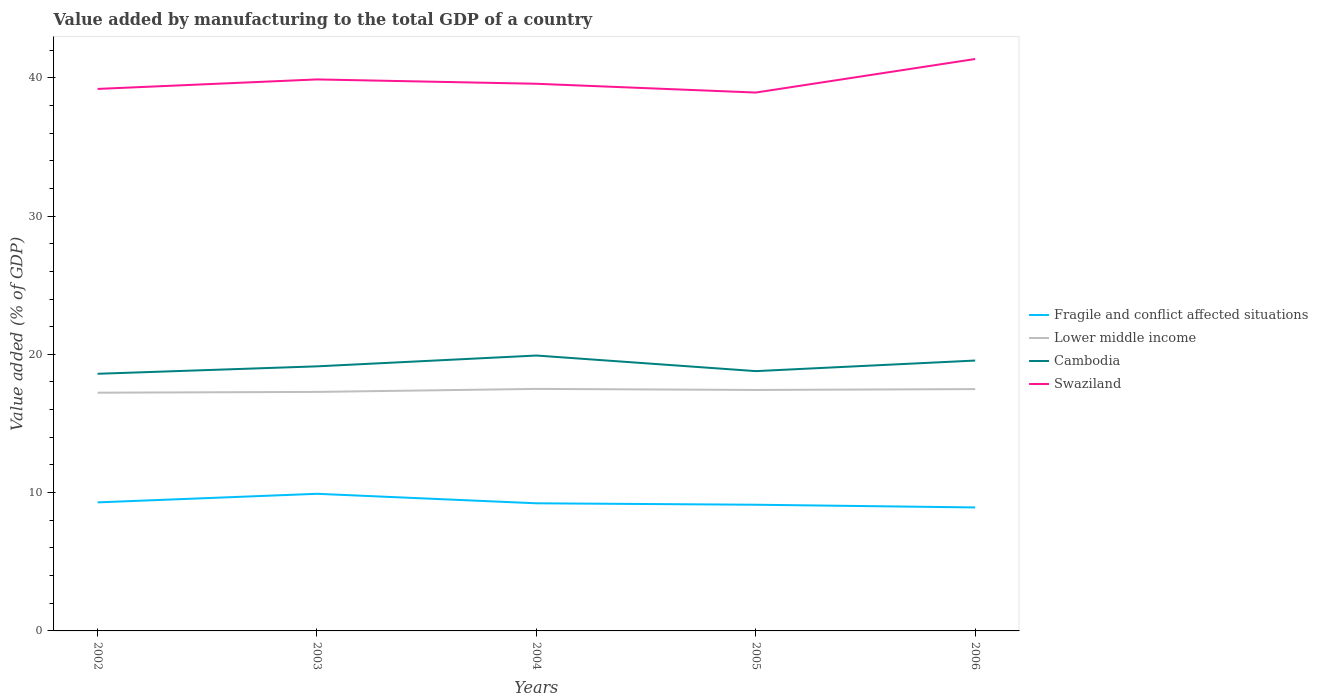Is the number of lines equal to the number of legend labels?
Your answer should be very brief. Yes. Across all years, what is the maximum value added by manufacturing to the total GDP in Cambodia?
Provide a short and direct response. 18.59. In which year was the value added by manufacturing to the total GDP in Fragile and conflict affected situations maximum?
Make the answer very short. 2006. What is the total value added by manufacturing to the total GDP in Cambodia in the graph?
Your response must be concise. -0.77. What is the difference between the highest and the second highest value added by manufacturing to the total GDP in Swaziland?
Your answer should be compact. 2.43. Is the value added by manufacturing to the total GDP in Cambodia strictly greater than the value added by manufacturing to the total GDP in Swaziland over the years?
Offer a very short reply. Yes. How many lines are there?
Provide a succinct answer. 4. How many years are there in the graph?
Your answer should be compact. 5. What is the difference between two consecutive major ticks on the Y-axis?
Provide a succinct answer. 10. Does the graph contain grids?
Ensure brevity in your answer.  No. How are the legend labels stacked?
Keep it short and to the point. Vertical. What is the title of the graph?
Give a very brief answer. Value added by manufacturing to the total GDP of a country. What is the label or title of the X-axis?
Provide a short and direct response. Years. What is the label or title of the Y-axis?
Ensure brevity in your answer.  Value added (% of GDP). What is the Value added (% of GDP) of Fragile and conflict affected situations in 2002?
Make the answer very short. 9.3. What is the Value added (% of GDP) in Lower middle income in 2002?
Offer a very short reply. 17.23. What is the Value added (% of GDP) in Cambodia in 2002?
Your response must be concise. 18.59. What is the Value added (% of GDP) in Swaziland in 2002?
Your answer should be very brief. 39.19. What is the Value added (% of GDP) in Fragile and conflict affected situations in 2003?
Give a very brief answer. 9.92. What is the Value added (% of GDP) of Lower middle income in 2003?
Offer a terse response. 17.28. What is the Value added (% of GDP) of Cambodia in 2003?
Provide a succinct answer. 19.13. What is the Value added (% of GDP) in Swaziland in 2003?
Provide a succinct answer. 39.88. What is the Value added (% of GDP) in Fragile and conflict affected situations in 2004?
Ensure brevity in your answer.  9.23. What is the Value added (% of GDP) of Lower middle income in 2004?
Provide a succinct answer. 17.5. What is the Value added (% of GDP) in Cambodia in 2004?
Your answer should be very brief. 19.91. What is the Value added (% of GDP) in Swaziland in 2004?
Offer a very short reply. 39.56. What is the Value added (% of GDP) in Fragile and conflict affected situations in 2005?
Your answer should be very brief. 9.12. What is the Value added (% of GDP) in Lower middle income in 2005?
Provide a succinct answer. 17.42. What is the Value added (% of GDP) in Cambodia in 2005?
Ensure brevity in your answer.  18.79. What is the Value added (% of GDP) in Swaziland in 2005?
Offer a terse response. 38.93. What is the Value added (% of GDP) in Fragile and conflict affected situations in 2006?
Provide a succinct answer. 8.93. What is the Value added (% of GDP) of Lower middle income in 2006?
Keep it short and to the point. 17.49. What is the Value added (% of GDP) of Cambodia in 2006?
Your answer should be compact. 19.55. What is the Value added (% of GDP) in Swaziland in 2006?
Your answer should be compact. 41.35. Across all years, what is the maximum Value added (% of GDP) in Fragile and conflict affected situations?
Ensure brevity in your answer.  9.92. Across all years, what is the maximum Value added (% of GDP) in Lower middle income?
Keep it short and to the point. 17.5. Across all years, what is the maximum Value added (% of GDP) in Cambodia?
Your answer should be very brief. 19.91. Across all years, what is the maximum Value added (% of GDP) of Swaziland?
Provide a succinct answer. 41.35. Across all years, what is the minimum Value added (% of GDP) of Fragile and conflict affected situations?
Offer a very short reply. 8.93. Across all years, what is the minimum Value added (% of GDP) of Lower middle income?
Offer a terse response. 17.23. Across all years, what is the minimum Value added (% of GDP) in Cambodia?
Your response must be concise. 18.59. Across all years, what is the minimum Value added (% of GDP) in Swaziland?
Make the answer very short. 38.93. What is the total Value added (% of GDP) of Fragile and conflict affected situations in the graph?
Keep it short and to the point. 46.49. What is the total Value added (% of GDP) in Lower middle income in the graph?
Your answer should be very brief. 86.92. What is the total Value added (% of GDP) in Cambodia in the graph?
Your answer should be compact. 95.97. What is the total Value added (% of GDP) in Swaziland in the graph?
Ensure brevity in your answer.  198.91. What is the difference between the Value added (% of GDP) in Fragile and conflict affected situations in 2002 and that in 2003?
Your answer should be compact. -0.62. What is the difference between the Value added (% of GDP) of Lower middle income in 2002 and that in 2003?
Give a very brief answer. -0.06. What is the difference between the Value added (% of GDP) in Cambodia in 2002 and that in 2003?
Ensure brevity in your answer.  -0.54. What is the difference between the Value added (% of GDP) in Swaziland in 2002 and that in 2003?
Offer a very short reply. -0.69. What is the difference between the Value added (% of GDP) of Fragile and conflict affected situations in 2002 and that in 2004?
Your response must be concise. 0.07. What is the difference between the Value added (% of GDP) in Lower middle income in 2002 and that in 2004?
Keep it short and to the point. -0.27. What is the difference between the Value added (% of GDP) in Cambodia in 2002 and that in 2004?
Ensure brevity in your answer.  -1.32. What is the difference between the Value added (% of GDP) of Swaziland in 2002 and that in 2004?
Your answer should be compact. -0.37. What is the difference between the Value added (% of GDP) of Fragile and conflict affected situations in 2002 and that in 2005?
Make the answer very short. 0.17. What is the difference between the Value added (% of GDP) in Lower middle income in 2002 and that in 2005?
Give a very brief answer. -0.2. What is the difference between the Value added (% of GDP) of Cambodia in 2002 and that in 2005?
Offer a terse response. -0.19. What is the difference between the Value added (% of GDP) in Swaziland in 2002 and that in 2005?
Your answer should be very brief. 0.26. What is the difference between the Value added (% of GDP) of Fragile and conflict affected situations in 2002 and that in 2006?
Keep it short and to the point. 0.37. What is the difference between the Value added (% of GDP) of Lower middle income in 2002 and that in 2006?
Make the answer very short. -0.26. What is the difference between the Value added (% of GDP) of Cambodia in 2002 and that in 2006?
Provide a succinct answer. -0.96. What is the difference between the Value added (% of GDP) in Swaziland in 2002 and that in 2006?
Provide a short and direct response. -2.16. What is the difference between the Value added (% of GDP) of Fragile and conflict affected situations in 2003 and that in 2004?
Your answer should be very brief. 0.69. What is the difference between the Value added (% of GDP) in Lower middle income in 2003 and that in 2004?
Offer a very short reply. -0.22. What is the difference between the Value added (% of GDP) of Cambodia in 2003 and that in 2004?
Offer a terse response. -0.78. What is the difference between the Value added (% of GDP) of Swaziland in 2003 and that in 2004?
Your answer should be very brief. 0.31. What is the difference between the Value added (% of GDP) in Fragile and conflict affected situations in 2003 and that in 2005?
Your answer should be compact. 0.79. What is the difference between the Value added (% of GDP) of Lower middle income in 2003 and that in 2005?
Your answer should be compact. -0.14. What is the difference between the Value added (% of GDP) in Cambodia in 2003 and that in 2005?
Offer a very short reply. 0.35. What is the difference between the Value added (% of GDP) in Swaziland in 2003 and that in 2005?
Give a very brief answer. 0.95. What is the difference between the Value added (% of GDP) in Fragile and conflict affected situations in 2003 and that in 2006?
Ensure brevity in your answer.  0.99. What is the difference between the Value added (% of GDP) in Lower middle income in 2003 and that in 2006?
Provide a short and direct response. -0.2. What is the difference between the Value added (% of GDP) of Cambodia in 2003 and that in 2006?
Offer a terse response. -0.42. What is the difference between the Value added (% of GDP) in Swaziland in 2003 and that in 2006?
Keep it short and to the point. -1.48. What is the difference between the Value added (% of GDP) in Fragile and conflict affected situations in 2004 and that in 2005?
Your answer should be very brief. 0.1. What is the difference between the Value added (% of GDP) in Lower middle income in 2004 and that in 2005?
Offer a terse response. 0.08. What is the difference between the Value added (% of GDP) of Cambodia in 2004 and that in 2005?
Your answer should be compact. 1.13. What is the difference between the Value added (% of GDP) of Swaziland in 2004 and that in 2005?
Offer a terse response. 0.64. What is the difference between the Value added (% of GDP) of Fragile and conflict affected situations in 2004 and that in 2006?
Keep it short and to the point. 0.3. What is the difference between the Value added (% of GDP) of Lower middle income in 2004 and that in 2006?
Provide a short and direct response. 0.01. What is the difference between the Value added (% of GDP) in Cambodia in 2004 and that in 2006?
Make the answer very short. 0.36. What is the difference between the Value added (% of GDP) of Swaziland in 2004 and that in 2006?
Ensure brevity in your answer.  -1.79. What is the difference between the Value added (% of GDP) of Fragile and conflict affected situations in 2005 and that in 2006?
Make the answer very short. 0.2. What is the difference between the Value added (% of GDP) in Lower middle income in 2005 and that in 2006?
Make the answer very short. -0.06. What is the difference between the Value added (% of GDP) in Cambodia in 2005 and that in 2006?
Provide a succinct answer. -0.77. What is the difference between the Value added (% of GDP) of Swaziland in 2005 and that in 2006?
Ensure brevity in your answer.  -2.43. What is the difference between the Value added (% of GDP) in Fragile and conflict affected situations in 2002 and the Value added (% of GDP) in Lower middle income in 2003?
Your answer should be very brief. -7.99. What is the difference between the Value added (% of GDP) in Fragile and conflict affected situations in 2002 and the Value added (% of GDP) in Cambodia in 2003?
Offer a terse response. -9.84. What is the difference between the Value added (% of GDP) of Fragile and conflict affected situations in 2002 and the Value added (% of GDP) of Swaziland in 2003?
Your answer should be compact. -30.58. What is the difference between the Value added (% of GDP) in Lower middle income in 2002 and the Value added (% of GDP) in Cambodia in 2003?
Keep it short and to the point. -1.9. What is the difference between the Value added (% of GDP) of Lower middle income in 2002 and the Value added (% of GDP) of Swaziland in 2003?
Offer a very short reply. -22.65. What is the difference between the Value added (% of GDP) in Cambodia in 2002 and the Value added (% of GDP) in Swaziland in 2003?
Provide a short and direct response. -21.28. What is the difference between the Value added (% of GDP) of Fragile and conflict affected situations in 2002 and the Value added (% of GDP) of Lower middle income in 2004?
Your answer should be very brief. -8.2. What is the difference between the Value added (% of GDP) of Fragile and conflict affected situations in 2002 and the Value added (% of GDP) of Cambodia in 2004?
Make the answer very short. -10.62. What is the difference between the Value added (% of GDP) in Fragile and conflict affected situations in 2002 and the Value added (% of GDP) in Swaziland in 2004?
Your response must be concise. -30.27. What is the difference between the Value added (% of GDP) of Lower middle income in 2002 and the Value added (% of GDP) of Cambodia in 2004?
Your answer should be compact. -2.69. What is the difference between the Value added (% of GDP) of Lower middle income in 2002 and the Value added (% of GDP) of Swaziland in 2004?
Make the answer very short. -22.34. What is the difference between the Value added (% of GDP) of Cambodia in 2002 and the Value added (% of GDP) of Swaziland in 2004?
Offer a very short reply. -20.97. What is the difference between the Value added (% of GDP) in Fragile and conflict affected situations in 2002 and the Value added (% of GDP) in Lower middle income in 2005?
Ensure brevity in your answer.  -8.13. What is the difference between the Value added (% of GDP) in Fragile and conflict affected situations in 2002 and the Value added (% of GDP) in Cambodia in 2005?
Offer a very short reply. -9.49. What is the difference between the Value added (% of GDP) of Fragile and conflict affected situations in 2002 and the Value added (% of GDP) of Swaziland in 2005?
Your answer should be very brief. -29.63. What is the difference between the Value added (% of GDP) in Lower middle income in 2002 and the Value added (% of GDP) in Cambodia in 2005?
Give a very brief answer. -1.56. What is the difference between the Value added (% of GDP) of Lower middle income in 2002 and the Value added (% of GDP) of Swaziland in 2005?
Give a very brief answer. -21.7. What is the difference between the Value added (% of GDP) of Cambodia in 2002 and the Value added (% of GDP) of Swaziland in 2005?
Make the answer very short. -20.33. What is the difference between the Value added (% of GDP) of Fragile and conflict affected situations in 2002 and the Value added (% of GDP) of Lower middle income in 2006?
Offer a very short reply. -8.19. What is the difference between the Value added (% of GDP) in Fragile and conflict affected situations in 2002 and the Value added (% of GDP) in Cambodia in 2006?
Keep it short and to the point. -10.26. What is the difference between the Value added (% of GDP) of Fragile and conflict affected situations in 2002 and the Value added (% of GDP) of Swaziland in 2006?
Keep it short and to the point. -32.06. What is the difference between the Value added (% of GDP) of Lower middle income in 2002 and the Value added (% of GDP) of Cambodia in 2006?
Ensure brevity in your answer.  -2.32. What is the difference between the Value added (% of GDP) in Lower middle income in 2002 and the Value added (% of GDP) in Swaziland in 2006?
Keep it short and to the point. -24.13. What is the difference between the Value added (% of GDP) in Cambodia in 2002 and the Value added (% of GDP) in Swaziland in 2006?
Your response must be concise. -22.76. What is the difference between the Value added (% of GDP) in Fragile and conflict affected situations in 2003 and the Value added (% of GDP) in Lower middle income in 2004?
Keep it short and to the point. -7.58. What is the difference between the Value added (% of GDP) in Fragile and conflict affected situations in 2003 and the Value added (% of GDP) in Cambodia in 2004?
Ensure brevity in your answer.  -10. What is the difference between the Value added (% of GDP) of Fragile and conflict affected situations in 2003 and the Value added (% of GDP) of Swaziland in 2004?
Your response must be concise. -29.65. What is the difference between the Value added (% of GDP) of Lower middle income in 2003 and the Value added (% of GDP) of Cambodia in 2004?
Offer a very short reply. -2.63. What is the difference between the Value added (% of GDP) of Lower middle income in 2003 and the Value added (% of GDP) of Swaziland in 2004?
Give a very brief answer. -22.28. What is the difference between the Value added (% of GDP) of Cambodia in 2003 and the Value added (% of GDP) of Swaziland in 2004?
Provide a short and direct response. -20.43. What is the difference between the Value added (% of GDP) of Fragile and conflict affected situations in 2003 and the Value added (% of GDP) of Lower middle income in 2005?
Your response must be concise. -7.51. What is the difference between the Value added (% of GDP) in Fragile and conflict affected situations in 2003 and the Value added (% of GDP) in Cambodia in 2005?
Provide a succinct answer. -8.87. What is the difference between the Value added (% of GDP) in Fragile and conflict affected situations in 2003 and the Value added (% of GDP) in Swaziland in 2005?
Your answer should be very brief. -29.01. What is the difference between the Value added (% of GDP) of Lower middle income in 2003 and the Value added (% of GDP) of Cambodia in 2005?
Your response must be concise. -1.5. What is the difference between the Value added (% of GDP) in Lower middle income in 2003 and the Value added (% of GDP) in Swaziland in 2005?
Your answer should be compact. -21.65. What is the difference between the Value added (% of GDP) in Cambodia in 2003 and the Value added (% of GDP) in Swaziland in 2005?
Make the answer very short. -19.8. What is the difference between the Value added (% of GDP) in Fragile and conflict affected situations in 2003 and the Value added (% of GDP) in Lower middle income in 2006?
Give a very brief answer. -7.57. What is the difference between the Value added (% of GDP) in Fragile and conflict affected situations in 2003 and the Value added (% of GDP) in Cambodia in 2006?
Keep it short and to the point. -9.64. What is the difference between the Value added (% of GDP) in Fragile and conflict affected situations in 2003 and the Value added (% of GDP) in Swaziland in 2006?
Your answer should be compact. -31.44. What is the difference between the Value added (% of GDP) of Lower middle income in 2003 and the Value added (% of GDP) of Cambodia in 2006?
Make the answer very short. -2.27. What is the difference between the Value added (% of GDP) of Lower middle income in 2003 and the Value added (% of GDP) of Swaziland in 2006?
Keep it short and to the point. -24.07. What is the difference between the Value added (% of GDP) of Cambodia in 2003 and the Value added (% of GDP) of Swaziland in 2006?
Give a very brief answer. -22.22. What is the difference between the Value added (% of GDP) of Fragile and conflict affected situations in 2004 and the Value added (% of GDP) of Lower middle income in 2005?
Your answer should be compact. -8.2. What is the difference between the Value added (% of GDP) of Fragile and conflict affected situations in 2004 and the Value added (% of GDP) of Cambodia in 2005?
Your response must be concise. -9.56. What is the difference between the Value added (% of GDP) in Fragile and conflict affected situations in 2004 and the Value added (% of GDP) in Swaziland in 2005?
Your answer should be very brief. -29.7. What is the difference between the Value added (% of GDP) of Lower middle income in 2004 and the Value added (% of GDP) of Cambodia in 2005?
Provide a succinct answer. -1.29. What is the difference between the Value added (% of GDP) in Lower middle income in 2004 and the Value added (% of GDP) in Swaziland in 2005?
Ensure brevity in your answer.  -21.43. What is the difference between the Value added (% of GDP) in Cambodia in 2004 and the Value added (% of GDP) in Swaziland in 2005?
Your answer should be very brief. -19.02. What is the difference between the Value added (% of GDP) of Fragile and conflict affected situations in 2004 and the Value added (% of GDP) of Lower middle income in 2006?
Your answer should be compact. -8.26. What is the difference between the Value added (% of GDP) of Fragile and conflict affected situations in 2004 and the Value added (% of GDP) of Cambodia in 2006?
Make the answer very short. -10.32. What is the difference between the Value added (% of GDP) of Fragile and conflict affected situations in 2004 and the Value added (% of GDP) of Swaziland in 2006?
Provide a short and direct response. -32.13. What is the difference between the Value added (% of GDP) of Lower middle income in 2004 and the Value added (% of GDP) of Cambodia in 2006?
Give a very brief answer. -2.05. What is the difference between the Value added (% of GDP) in Lower middle income in 2004 and the Value added (% of GDP) in Swaziland in 2006?
Offer a very short reply. -23.85. What is the difference between the Value added (% of GDP) in Cambodia in 2004 and the Value added (% of GDP) in Swaziland in 2006?
Ensure brevity in your answer.  -21.44. What is the difference between the Value added (% of GDP) in Fragile and conflict affected situations in 2005 and the Value added (% of GDP) in Lower middle income in 2006?
Keep it short and to the point. -8.36. What is the difference between the Value added (% of GDP) in Fragile and conflict affected situations in 2005 and the Value added (% of GDP) in Cambodia in 2006?
Your response must be concise. -10.43. What is the difference between the Value added (% of GDP) in Fragile and conflict affected situations in 2005 and the Value added (% of GDP) in Swaziland in 2006?
Your answer should be compact. -32.23. What is the difference between the Value added (% of GDP) of Lower middle income in 2005 and the Value added (% of GDP) of Cambodia in 2006?
Ensure brevity in your answer.  -2.13. What is the difference between the Value added (% of GDP) of Lower middle income in 2005 and the Value added (% of GDP) of Swaziland in 2006?
Keep it short and to the point. -23.93. What is the difference between the Value added (% of GDP) in Cambodia in 2005 and the Value added (% of GDP) in Swaziland in 2006?
Offer a very short reply. -22.57. What is the average Value added (% of GDP) in Fragile and conflict affected situations per year?
Make the answer very short. 9.3. What is the average Value added (% of GDP) in Lower middle income per year?
Offer a terse response. 17.38. What is the average Value added (% of GDP) in Cambodia per year?
Provide a succinct answer. 19.19. What is the average Value added (% of GDP) in Swaziland per year?
Provide a succinct answer. 39.78. In the year 2002, what is the difference between the Value added (% of GDP) of Fragile and conflict affected situations and Value added (% of GDP) of Lower middle income?
Your answer should be compact. -7.93. In the year 2002, what is the difference between the Value added (% of GDP) of Fragile and conflict affected situations and Value added (% of GDP) of Cambodia?
Your answer should be compact. -9.3. In the year 2002, what is the difference between the Value added (% of GDP) in Fragile and conflict affected situations and Value added (% of GDP) in Swaziland?
Give a very brief answer. -29.9. In the year 2002, what is the difference between the Value added (% of GDP) in Lower middle income and Value added (% of GDP) in Cambodia?
Your answer should be very brief. -1.37. In the year 2002, what is the difference between the Value added (% of GDP) of Lower middle income and Value added (% of GDP) of Swaziland?
Offer a very short reply. -21.96. In the year 2002, what is the difference between the Value added (% of GDP) of Cambodia and Value added (% of GDP) of Swaziland?
Keep it short and to the point. -20.6. In the year 2003, what is the difference between the Value added (% of GDP) in Fragile and conflict affected situations and Value added (% of GDP) in Lower middle income?
Ensure brevity in your answer.  -7.37. In the year 2003, what is the difference between the Value added (% of GDP) of Fragile and conflict affected situations and Value added (% of GDP) of Cambodia?
Offer a terse response. -9.22. In the year 2003, what is the difference between the Value added (% of GDP) in Fragile and conflict affected situations and Value added (% of GDP) in Swaziland?
Give a very brief answer. -29.96. In the year 2003, what is the difference between the Value added (% of GDP) in Lower middle income and Value added (% of GDP) in Cambodia?
Make the answer very short. -1.85. In the year 2003, what is the difference between the Value added (% of GDP) in Lower middle income and Value added (% of GDP) in Swaziland?
Your response must be concise. -22.6. In the year 2003, what is the difference between the Value added (% of GDP) of Cambodia and Value added (% of GDP) of Swaziland?
Provide a succinct answer. -20.75. In the year 2004, what is the difference between the Value added (% of GDP) of Fragile and conflict affected situations and Value added (% of GDP) of Lower middle income?
Your answer should be very brief. -8.27. In the year 2004, what is the difference between the Value added (% of GDP) of Fragile and conflict affected situations and Value added (% of GDP) of Cambodia?
Your answer should be very brief. -10.69. In the year 2004, what is the difference between the Value added (% of GDP) in Fragile and conflict affected situations and Value added (% of GDP) in Swaziland?
Offer a very short reply. -30.34. In the year 2004, what is the difference between the Value added (% of GDP) of Lower middle income and Value added (% of GDP) of Cambodia?
Offer a very short reply. -2.41. In the year 2004, what is the difference between the Value added (% of GDP) of Lower middle income and Value added (% of GDP) of Swaziland?
Provide a succinct answer. -22.06. In the year 2004, what is the difference between the Value added (% of GDP) in Cambodia and Value added (% of GDP) in Swaziland?
Make the answer very short. -19.65. In the year 2005, what is the difference between the Value added (% of GDP) in Fragile and conflict affected situations and Value added (% of GDP) in Lower middle income?
Your answer should be very brief. -8.3. In the year 2005, what is the difference between the Value added (% of GDP) in Fragile and conflict affected situations and Value added (% of GDP) in Cambodia?
Give a very brief answer. -9.66. In the year 2005, what is the difference between the Value added (% of GDP) in Fragile and conflict affected situations and Value added (% of GDP) in Swaziland?
Provide a succinct answer. -29.8. In the year 2005, what is the difference between the Value added (% of GDP) in Lower middle income and Value added (% of GDP) in Cambodia?
Keep it short and to the point. -1.36. In the year 2005, what is the difference between the Value added (% of GDP) in Lower middle income and Value added (% of GDP) in Swaziland?
Your response must be concise. -21.5. In the year 2005, what is the difference between the Value added (% of GDP) in Cambodia and Value added (% of GDP) in Swaziland?
Make the answer very short. -20.14. In the year 2006, what is the difference between the Value added (% of GDP) of Fragile and conflict affected situations and Value added (% of GDP) of Lower middle income?
Your answer should be very brief. -8.56. In the year 2006, what is the difference between the Value added (% of GDP) in Fragile and conflict affected situations and Value added (% of GDP) in Cambodia?
Provide a short and direct response. -10.62. In the year 2006, what is the difference between the Value added (% of GDP) of Fragile and conflict affected situations and Value added (% of GDP) of Swaziland?
Keep it short and to the point. -32.43. In the year 2006, what is the difference between the Value added (% of GDP) of Lower middle income and Value added (% of GDP) of Cambodia?
Ensure brevity in your answer.  -2.06. In the year 2006, what is the difference between the Value added (% of GDP) in Lower middle income and Value added (% of GDP) in Swaziland?
Keep it short and to the point. -23.87. In the year 2006, what is the difference between the Value added (% of GDP) in Cambodia and Value added (% of GDP) in Swaziland?
Ensure brevity in your answer.  -21.8. What is the ratio of the Value added (% of GDP) of Lower middle income in 2002 to that in 2003?
Offer a terse response. 1. What is the ratio of the Value added (% of GDP) of Cambodia in 2002 to that in 2003?
Offer a very short reply. 0.97. What is the ratio of the Value added (% of GDP) of Swaziland in 2002 to that in 2003?
Your answer should be very brief. 0.98. What is the ratio of the Value added (% of GDP) of Fragile and conflict affected situations in 2002 to that in 2004?
Keep it short and to the point. 1.01. What is the ratio of the Value added (% of GDP) of Lower middle income in 2002 to that in 2004?
Provide a short and direct response. 0.98. What is the ratio of the Value added (% of GDP) in Cambodia in 2002 to that in 2004?
Offer a terse response. 0.93. What is the ratio of the Value added (% of GDP) of Swaziland in 2002 to that in 2004?
Make the answer very short. 0.99. What is the ratio of the Value added (% of GDP) of Fragile and conflict affected situations in 2002 to that in 2005?
Ensure brevity in your answer.  1.02. What is the ratio of the Value added (% of GDP) in Lower middle income in 2002 to that in 2005?
Keep it short and to the point. 0.99. What is the ratio of the Value added (% of GDP) in Swaziland in 2002 to that in 2005?
Your answer should be very brief. 1.01. What is the ratio of the Value added (% of GDP) in Fragile and conflict affected situations in 2002 to that in 2006?
Provide a short and direct response. 1.04. What is the ratio of the Value added (% of GDP) in Lower middle income in 2002 to that in 2006?
Your response must be concise. 0.99. What is the ratio of the Value added (% of GDP) in Cambodia in 2002 to that in 2006?
Ensure brevity in your answer.  0.95. What is the ratio of the Value added (% of GDP) in Swaziland in 2002 to that in 2006?
Give a very brief answer. 0.95. What is the ratio of the Value added (% of GDP) in Fragile and conflict affected situations in 2003 to that in 2004?
Offer a very short reply. 1.07. What is the ratio of the Value added (% of GDP) of Lower middle income in 2003 to that in 2004?
Offer a terse response. 0.99. What is the ratio of the Value added (% of GDP) in Cambodia in 2003 to that in 2004?
Give a very brief answer. 0.96. What is the ratio of the Value added (% of GDP) in Swaziland in 2003 to that in 2004?
Make the answer very short. 1.01. What is the ratio of the Value added (% of GDP) in Fragile and conflict affected situations in 2003 to that in 2005?
Provide a short and direct response. 1.09. What is the ratio of the Value added (% of GDP) in Cambodia in 2003 to that in 2005?
Ensure brevity in your answer.  1.02. What is the ratio of the Value added (% of GDP) in Swaziland in 2003 to that in 2005?
Your answer should be very brief. 1.02. What is the ratio of the Value added (% of GDP) in Fragile and conflict affected situations in 2003 to that in 2006?
Ensure brevity in your answer.  1.11. What is the ratio of the Value added (% of GDP) of Lower middle income in 2003 to that in 2006?
Offer a terse response. 0.99. What is the ratio of the Value added (% of GDP) of Cambodia in 2003 to that in 2006?
Make the answer very short. 0.98. What is the ratio of the Value added (% of GDP) of Fragile and conflict affected situations in 2004 to that in 2005?
Make the answer very short. 1.01. What is the ratio of the Value added (% of GDP) in Lower middle income in 2004 to that in 2005?
Make the answer very short. 1. What is the ratio of the Value added (% of GDP) of Cambodia in 2004 to that in 2005?
Give a very brief answer. 1.06. What is the ratio of the Value added (% of GDP) in Swaziland in 2004 to that in 2005?
Give a very brief answer. 1.02. What is the ratio of the Value added (% of GDP) of Fragile and conflict affected situations in 2004 to that in 2006?
Your answer should be compact. 1.03. What is the ratio of the Value added (% of GDP) in Cambodia in 2004 to that in 2006?
Make the answer very short. 1.02. What is the ratio of the Value added (% of GDP) of Swaziland in 2004 to that in 2006?
Provide a succinct answer. 0.96. What is the ratio of the Value added (% of GDP) of Cambodia in 2005 to that in 2006?
Offer a very short reply. 0.96. What is the ratio of the Value added (% of GDP) of Swaziland in 2005 to that in 2006?
Provide a succinct answer. 0.94. What is the difference between the highest and the second highest Value added (% of GDP) of Fragile and conflict affected situations?
Keep it short and to the point. 0.62. What is the difference between the highest and the second highest Value added (% of GDP) in Lower middle income?
Keep it short and to the point. 0.01. What is the difference between the highest and the second highest Value added (% of GDP) in Cambodia?
Keep it short and to the point. 0.36. What is the difference between the highest and the second highest Value added (% of GDP) of Swaziland?
Keep it short and to the point. 1.48. What is the difference between the highest and the lowest Value added (% of GDP) of Fragile and conflict affected situations?
Provide a short and direct response. 0.99. What is the difference between the highest and the lowest Value added (% of GDP) of Lower middle income?
Provide a short and direct response. 0.27. What is the difference between the highest and the lowest Value added (% of GDP) in Cambodia?
Provide a succinct answer. 1.32. What is the difference between the highest and the lowest Value added (% of GDP) of Swaziland?
Your answer should be very brief. 2.43. 